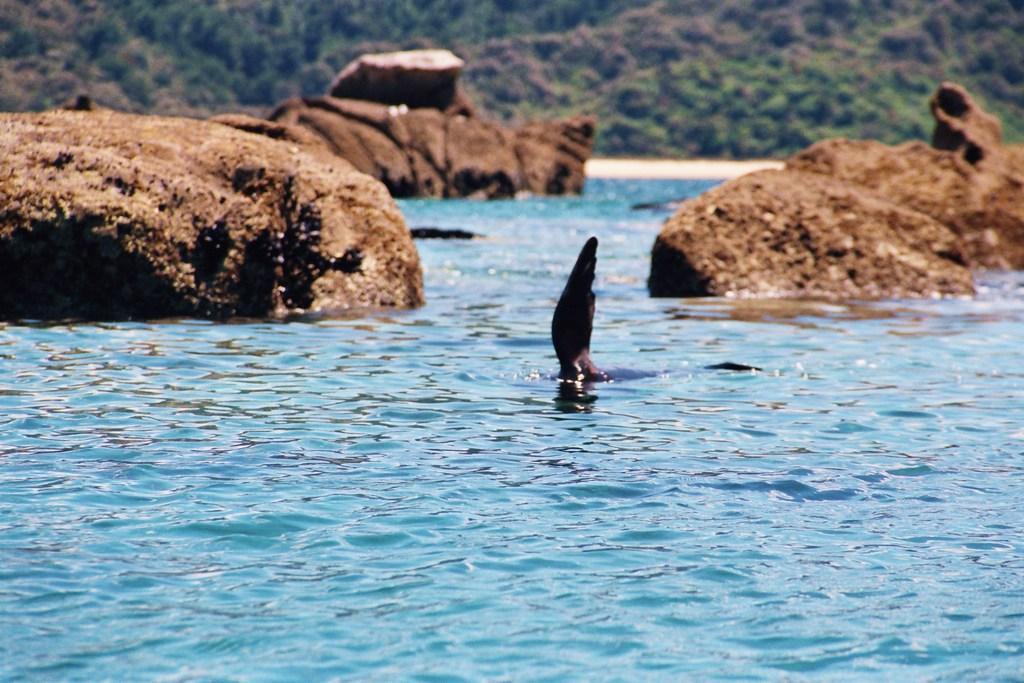Please provide a concise description of this image. In the foreground of this picture, there is a fin of an animal in the water. In the background, there are rocks, trees and the sand. 